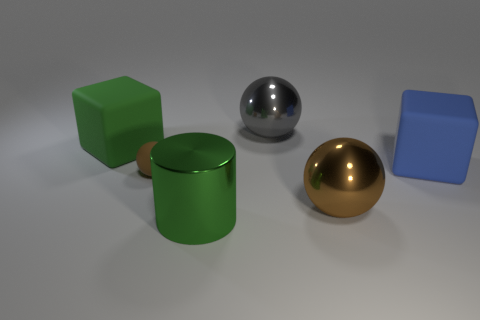What number of balls are made of the same material as the large green cylinder?
Provide a succinct answer. 2. There is a block right of the metallic cylinder; is it the same size as the large green cylinder?
Offer a terse response. Yes. There is another cube that is the same size as the green rubber cube; what color is it?
Ensure brevity in your answer.  Blue. What number of large blue matte cubes are in front of the large gray object?
Your response must be concise. 1. Is there a large brown metal thing?
Keep it short and to the point. Yes. What size is the block to the left of the large metallic object in front of the big metal sphere that is to the right of the large gray metallic sphere?
Your response must be concise. Large. What number of other objects are there of the same size as the blue object?
Provide a succinct answer. 4. There is a green object that is in front of the big blue object; what is its size?
Ensure brevity in your answer.  Large. Are there any other things that are the same color as the small matte object?
Your answer should be very brief. Yes. Is the material of the green object that is behind the matte ball the same as the cylinder?
Ensure brevity in your answer.  No. 